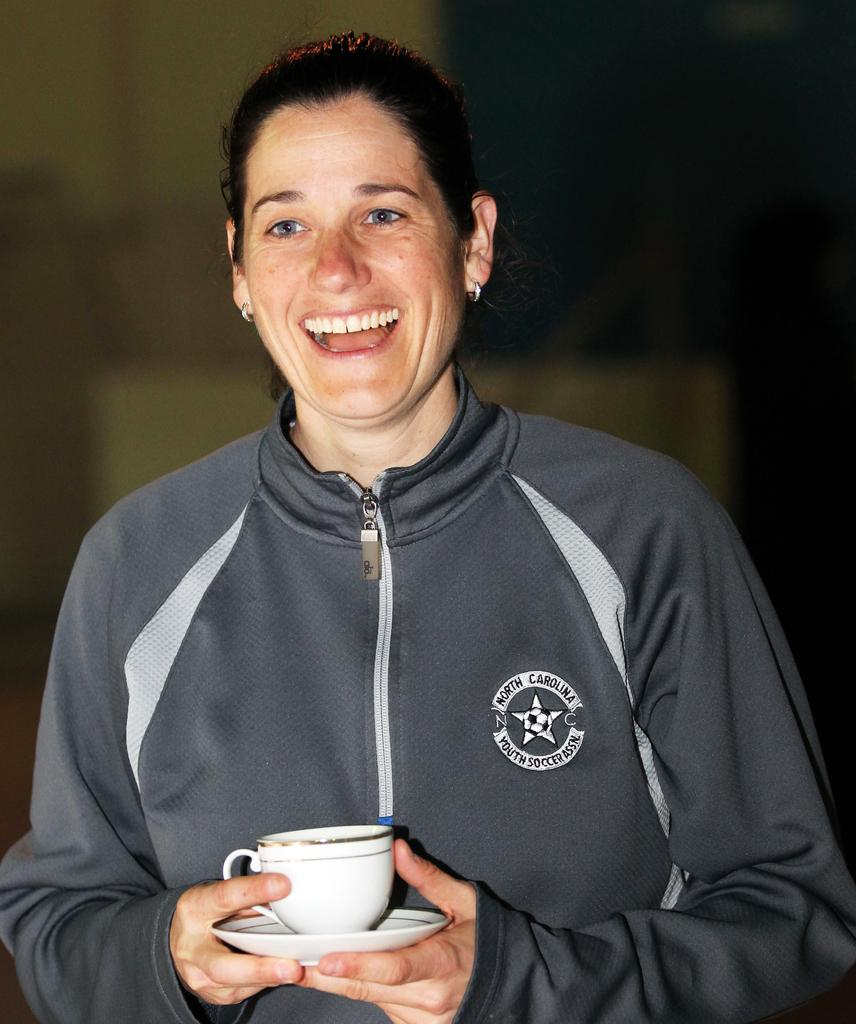Who or what is the main subject in the image? There is a person in the image. Can you describe the person's position in the image? The person is standing in the middle of the image. What is the person holding in the image? The person is holding a white color coffee cup. What is the person's facial expression in the image? The person is smiling. What type of property does the monkey own in the image? There is no monkey present in the image, and therefore no property owned by a monkey can be observed. 